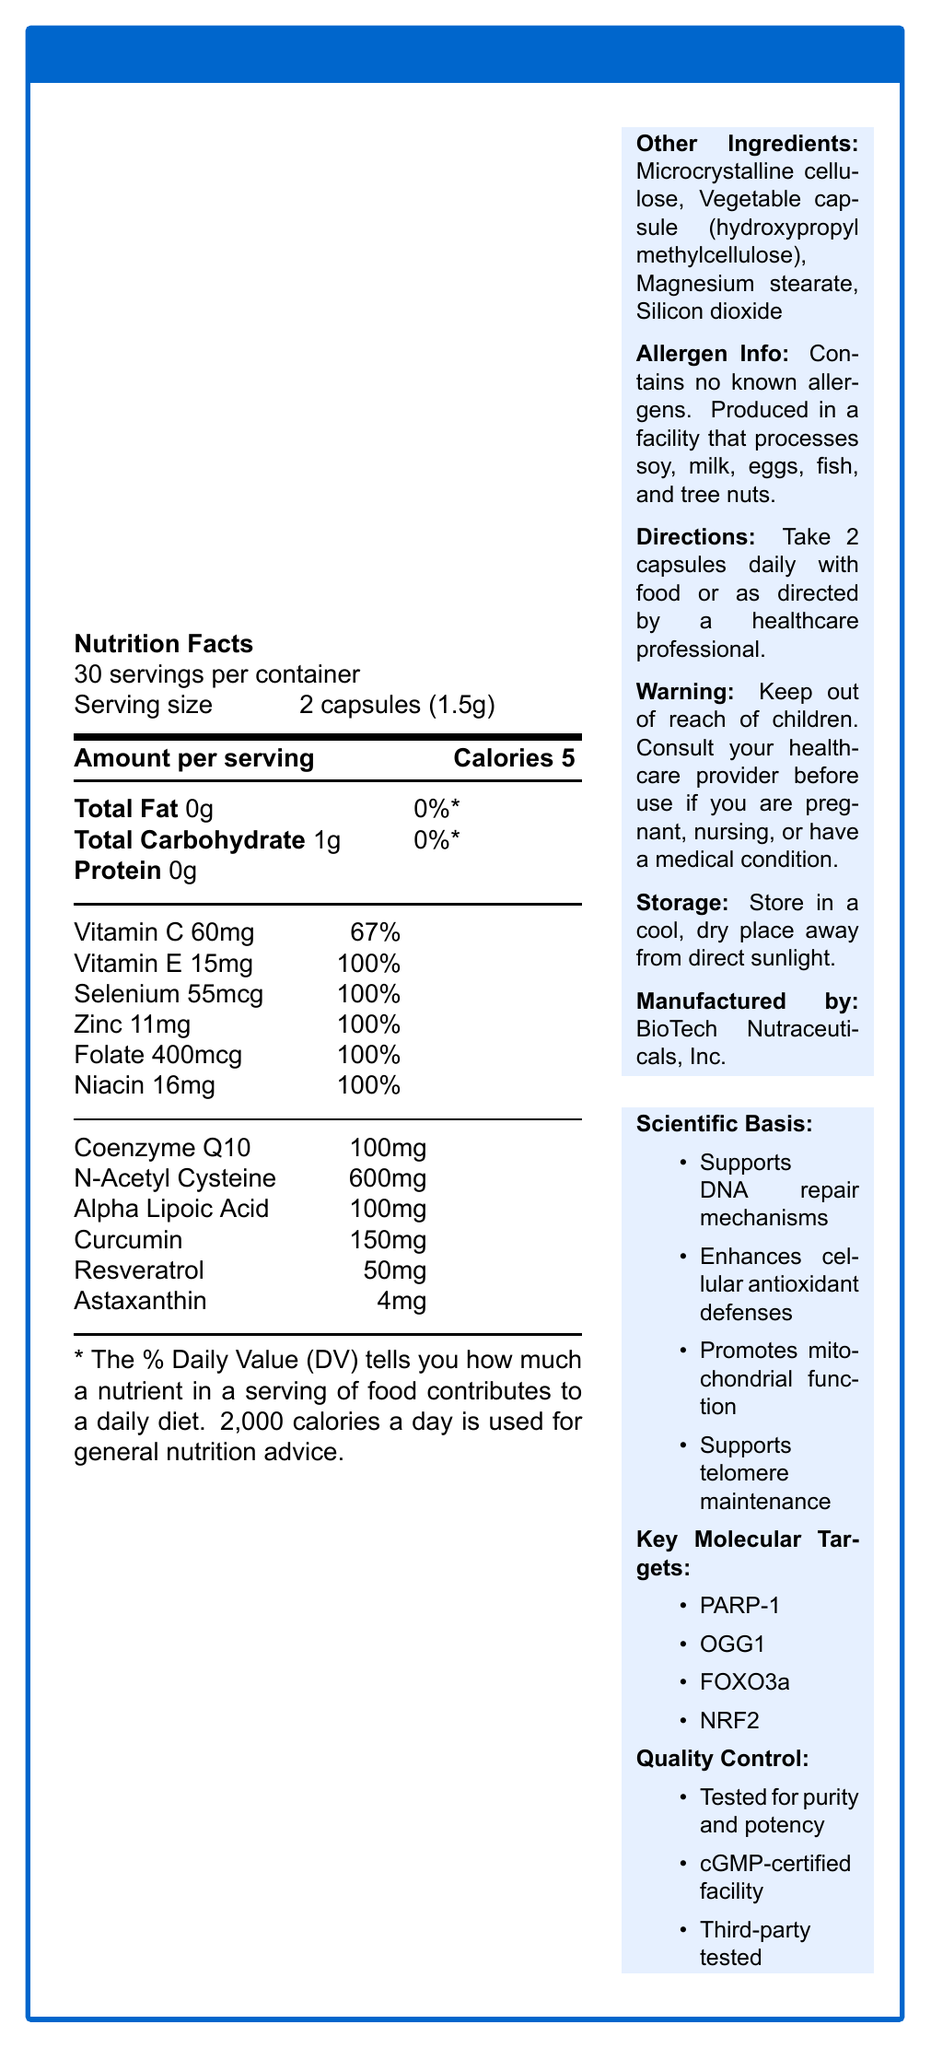what is the serving size of CellGuard DNA Repair Complex? The document specifies the serving size as "2 capsules (1.5g)".
Answer: 2 capsules (1.5g) how many servings per container are there? The document states that there are 30 servings per container.
Answer: 30 how many calories are in each serving? The Nutrition Facts section lists the calories per serving as 5.
Answer: 5 what is the total amount of Vitamin C in one serving? The document indicates that each serving contains 60mg of Vitamin C.
Answer: 60mg which mineral is present in the highest quantity per serving? A. Selenium B. Zinc C. Folate Zinc is present at 11mg per serving, which is higher than Selenium (55mcg) and Folate (400mcg).
Answer: B. Zinc is this product suitable for those with allergies to soy, milk, eggs, fish, or tree nuts? The allergen info states that the product contains no known allergens but is produced in a facility that processes soy, milk, eggs, fish, and tree nuts.
Answer: No how should CellGuard DNA Repair Complex be stored? The document instructs users to store the product in a cool, dry place away from direct sunlight.
Answer: Store in a cool, dry place away from direct sunlight which ingredient is present in the largest quantity? The document lists N-Acetyl Cysteine as having 600mg per serving, which is the largest quantity among the listed ingredients.
Answer: N-Acetyl Cysteine which is not a benefit of the CellGuard DNA Repair Complex? A. Enhances cognitive function B. Supports DNA repair mechanisms C. Promotes mitochondrial function The document mentions supporting DNA repair mechanisms, enhancing cellular antioxidant defenses, promoting mitochondrial function, and supporting telomere maintenance, but it does not mention enhancing cognitive function.
Answer: A. Enhances cognitive function does one serving contain any protein? The Nutrition Facts section lists Protein as 0g per serving.
Answer: No is the product tested for contaminants and heavy metals? Under the Quality Control section, the document states that the product is third-party tested for contaminants and heavy metals.
Answer: Yes summarize the key functions of CellGuard DNA Repair Complex. The document lists these functions under the Scientific Basis section, summarizing the main benefits of the supplement.
Answer: Supports DNA repair, enhances antioxidant defenses, promotes mitochondrial function, supports telomere maintenance what are the key molecular targets of the product? The document lists these molecular targets in the Key Molecular Targets section.
Answer: PARP-1, OGG1, FOXO3a, NRF2 when should one consult a healthcare provider before using this product? The warning section advises consultation with a healthcare provider if pregnant, nursing, or having a medical condition.
Answer: If you are pregnant, nursing, or have a medical condition. how is the product purity and potency tested? A. HPLC and mass spectrometry B. HPLC and spectroscopy C. Mass spectrometry and chromatography The Quality Control section mentions it is tested for purity and potency using HPLC and mass spectrometry.
Answer: A. HPLC and mass spectrometry what is the main ingredient used for the capsule? The Other Ingredients section lists the vegetable capsule made of hydroxypropyl methylcellulose.
Answer: Vegetable capsule (hydroxypropyl methylcellulose) is this product manufactured in a certified facility? The Quality Control section states that it is manufactured in a cGMP-certified facility.
Answer: Yes what is the role of curcumin in the supplement? The document does not provide specific details on the role of curcumin. It only lists it as an ingredient.
Answer: Cannot be determined 